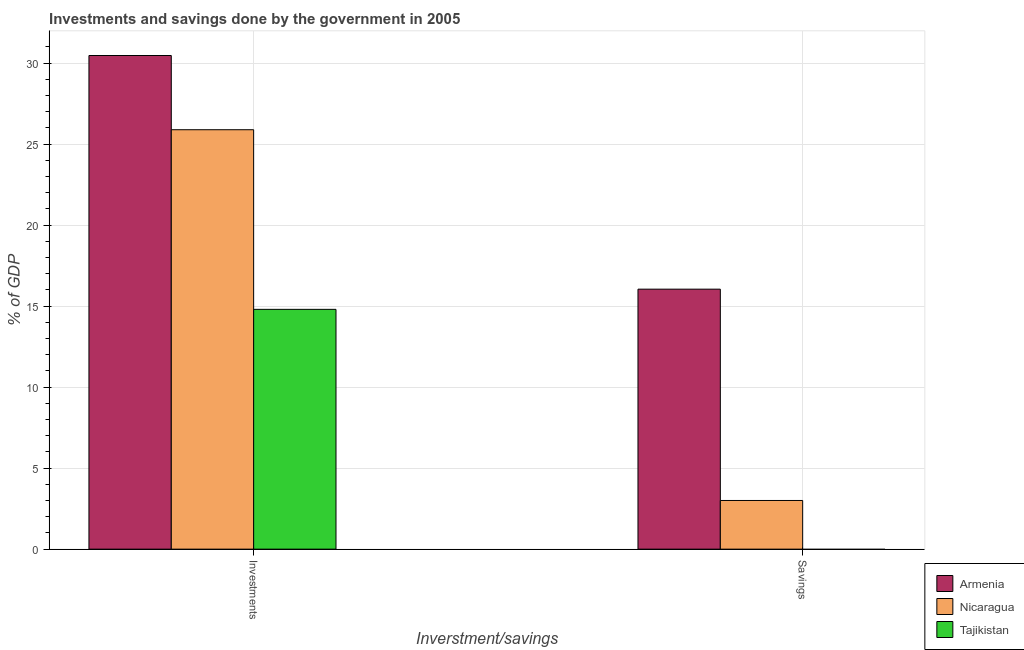Are the number of bars per tick equal to the number of legend labels?
Provide a short and direct response. No. Are the number of bars on each tick of the X-axis equal?
Make the answer very short. No. How many bars are there on the 1st tick from the left?
Give a very brief answer. 3. What is the label of the 2nd group of bars from the left?
Keep it short and to the point. Savings. What is the investments of government in Nicaragua?
Your answer should be compact. 25.89. Across all countries, what is the maximum investments of government?
Keep it short and to the point. 30.47. Across all countries, what is the minimum investments of government?
Provide a succinct answer. 14.8. In which country was the investments of government maximum?
Offer a terse response. Armenia. What is the total investments of government in the graph?
Make the answer very short. 71.15. What is the difference between the investments of government in Nicaragua and that in Tajikistan?
Offer a very short reply. 11.09. What is the difference between the investments of government in Tajikistan and the savings of government in Nicaragua?
Your answer should be compact. 11.8. What is the average savings of government per country?
Your answer should be compact. 6.35. What is the difference between the savings of government and investments of government in Nicaragua?
Ensure brevity in your answer.  -22.88. In how many countries, is the investments of government greater than 28 %?
Offer a terse response. 1. What is the ratio of the investments of government in Tajikistan to that in Armenia?
Ensure brevity in your answer.  0.49. In how many countries, is the savings of government greater than the average savings of government taken over all countries?
Give a very brief answer. 1. Are all the bars in the graph horizontal?
Make the answer very short. No. What is the difference between two consecutive major ticks on the Y-axis?
Ensure brevity in your answer.  5. Does the graph contain grids?
Your response must be concise. Yes. How many legend labels are there?
Make the answer very short. 3. What is the title of the graph?
Your answer should be compact. Investments and savings done by the government in 2005. Does "Mongolia" appear as one of the legend labels in the graph?
Offer a terse response. No. What is the label or title of the X-axis?
Offer a very short reply. Inverstment/savings. What is the label or title of the Y-axis?
Your response must be concise. % of GDP. What is the % of GDP in Armenia in Investments?
Offer a very short reply. 30.47. What is the % of GDP in Nicaragua in Investments?
Your answer should be very brief. 25.89. What is the % of GDP in Armenia in Savings?
Make the answer very short. 16.05. What is the % of GDP in Nicaragua in Savings?
Give a very brief answer. 3. Across all Inverstment/savings, what is the maximum % of GDP in Armenia?
Your answer should be compact. 30.47. Across all Inverstment/savings, what is the maximum % of GDP in Nicaragua?
Ensure brevity in your answer.  25.89. Across all Inverstment/savings, what is the minimum % of GDP of Armenia?
Give a very brief answer. 16.05. Across all Inverstment/savings, what is the minimum % of GDP in Nicaragua?
Make the answer very short. 3. What is the total % of GDP of Armenia in the graph?
Offer a very short reply. 46.51. What is the total % of GDP of Nicaragua in the graph?
Offer a very short reply. 28.89. What is the total % of GDP in Tajikistan in the graph?
Keep it short and to the point. 14.8. What is the difference between the % of GDP of Armenia in Investments and that in Savings?
Give a very brief answer. 14.42. What is the difference between the % of GDP in Nicaragua in Investments and that in Savings?
Ensure brevity in your answer.  22.88. What is the difference between the % of GDP of Armenia in Investments and the % of GDP of Nicaragua in Savings?
Provide a short and direct response. 27.46. What is the average % of GDP of Armenia per Inverstment/savings?
Your answer should be compact. 23.26. What is the average % of GDP of Nicaragua per Inverstment/savings?
Provide a succinct answer. 14.44. What is the average % of GDP of Tajikistan per Inverstment/savings?
Your answer should be compact. 7.4. What is the difference between the % of GDP in Armenia and % of GDP in Nicaragua in Investments?
Provide a short and direct response. 4.58. What is the difference between the % of GDP of Armenia and % of GDP of Tajikistan in Investments?
Keep it short and to the point. 15.67. What is the difference between the % of GDP in Nicaragua and % of GDP in Tajikistan in Investments?
Make the answer very short. 11.09. What is the difference between the % of GDP of Armenia and % of GDP of Nicaragua in Savings?
Your answer should be very brief. 13.04. What is the ratio of the % of GDP of Armenia in Investments to that in Savings?
Make the answer very short. 1.9. What is the ratio of the % of GDP of Nicaragua in Investments to that in Savings?
Provide a short and direct response. 8.62. What is the difference between the highest and the second highest % of GDP in Armenia?
Your answer should be very brief. 14.42. What is the difference between the highest and the second highest % of GDP of Nicaragua?
Your answer should be very brief. 22.88. What is the difference between the highest and the lowest % of GDP in Armenia?
Ensure brevity in your answer.  14.42. What is the difference between the highest and the lowest % of GDP of Nicaragua?
Keep it short and to the point. 22.88. What is the difference between the highest and the lowest % of GDP of Tajikistan?
Make the answer very short. 14.8. 